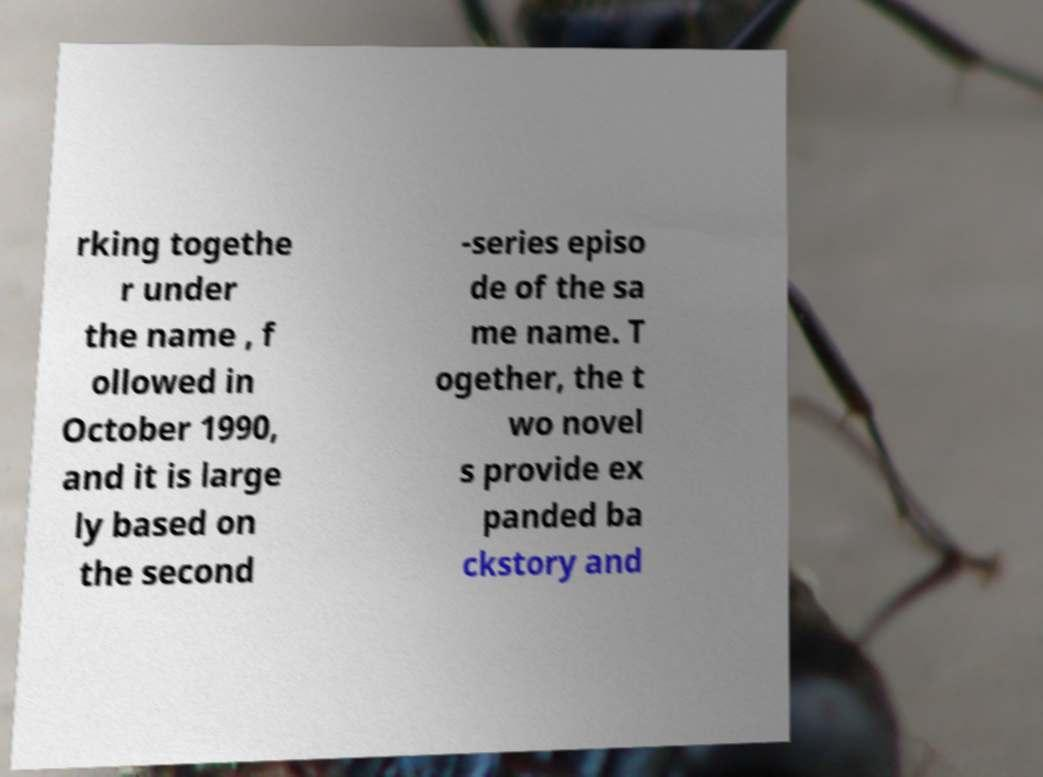I need the written content from this picture converted into text. Can you do that? rking togethe r under the name , f ollowed in October 1990, and it is large ly based on the second -series episo de of the sa me name. T ogether, the t wo novel s provide ex panded ba ckstory and 